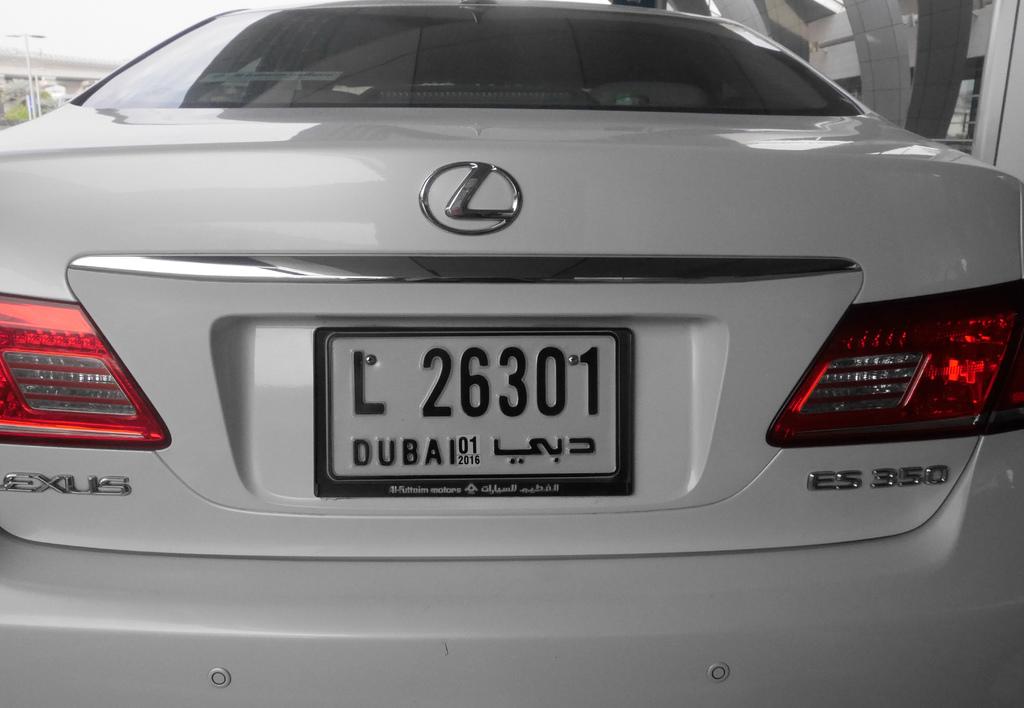What is the plate no of this car?
Keep it short and to the point. L 26301. 